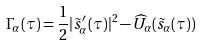Convert formula to latex. <formula><loc_0><loc_0><loc_500><loc_500>\Gamma _ { \alpha } ( \tau ) = \frac { 1 } { 2 } | \tilde { s } ^ { \prime } _ { \alpha } ( \tau ) | ^ { 2 } - \widehat { U } _ { \alpha } ( \tilde { s } _ { \alpha } ( \tau ) )</formula> 